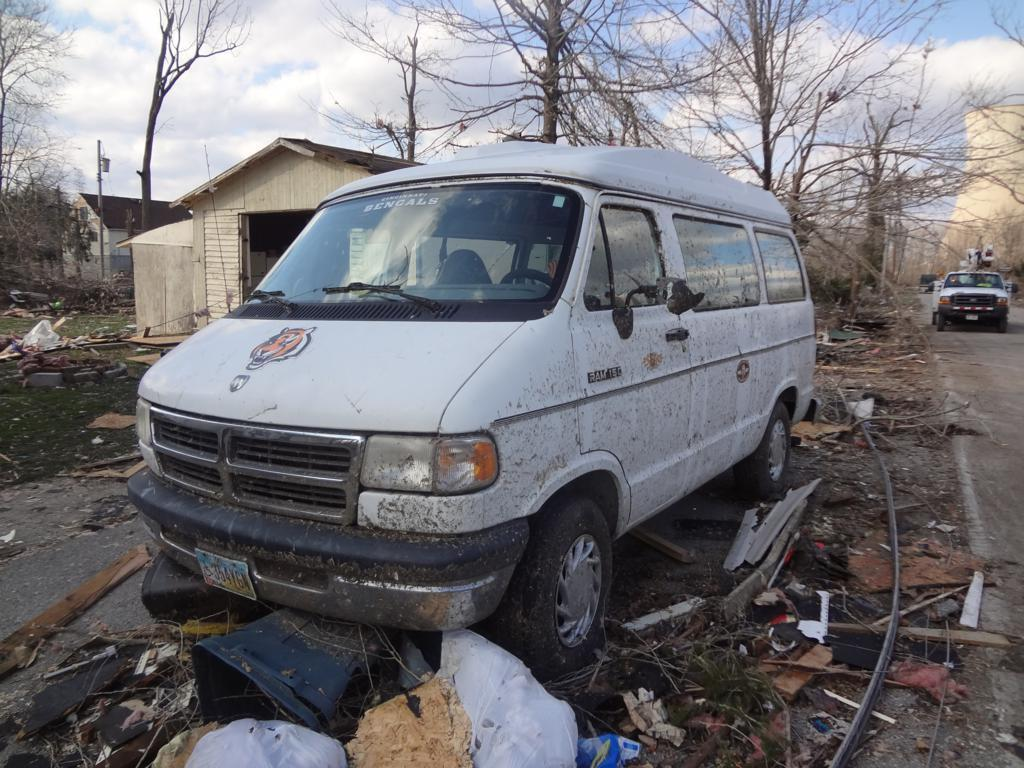<image>
Create a compact narrative representing the image presented. A dirty white van with a tiger on the front and a Bengals sticker on the windshield. 